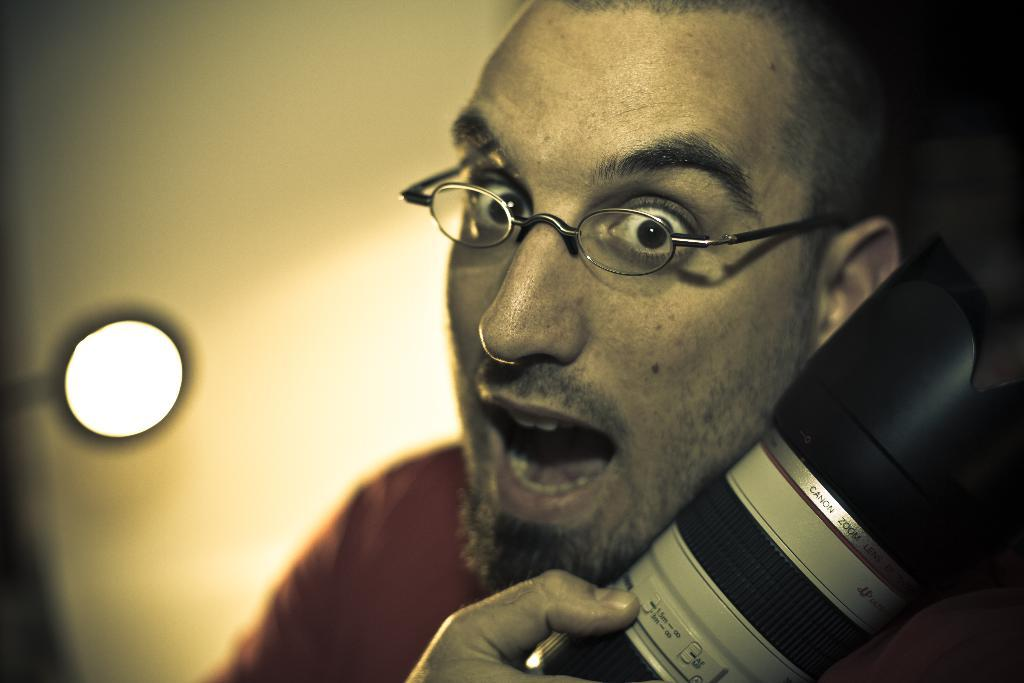Who is the main subject in the image? There is a person in the center of the image. What can be seen on the person's face? The person is wearing glasses. What is the person holding in the image? The person is holding a camera. What can be seen in the background of the image? There is a light and a wall in the background of the image. How many bubbles are floating around the person in the image? There are no bubbles present in the image. What is the date of the person's birth as depicted in the image? There is no information about the person's birth in the image. 